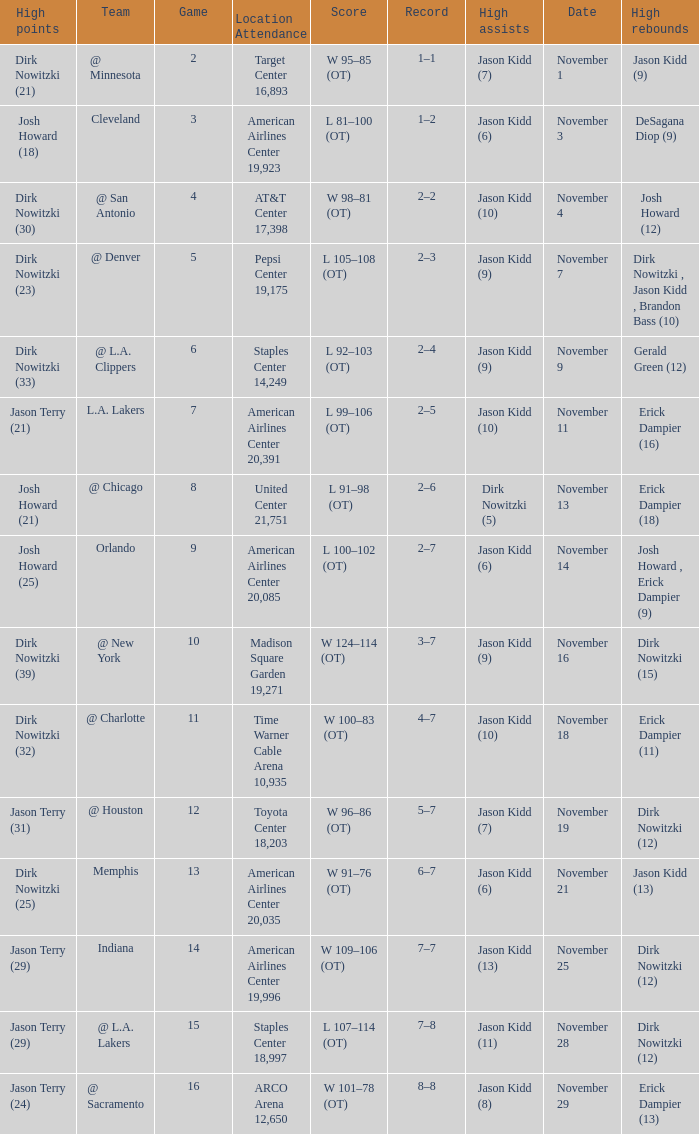What is High Rebounds, when High Assists is "Jason Kidd (13)"? Dirk Nowitzki (12). 